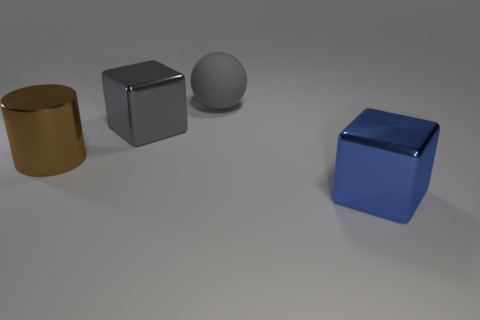Subtract all gray cubes. How many cubes are left? 1 Subtract 1 balls. How many balls are left? 0 Subtract all purple blocks. Subtract all gray cylinders. How many blocks are left? 2 Subtract all purple balls. How many gray cubes are left? 1 Subtract all big matte things. Subtract all metallic things. How many objects are left? 0 Add 3 large gray things. How many large gray things are left? 5 Add 2 big gray cubes. How many big gray cubes exist? 3 Add 2 tiny cyan rubber things. How many objects exist? 6 Subtract 0 cyan cylinders. How many objects are left? 4 Subtract all spheres. How many objects are left? 3 